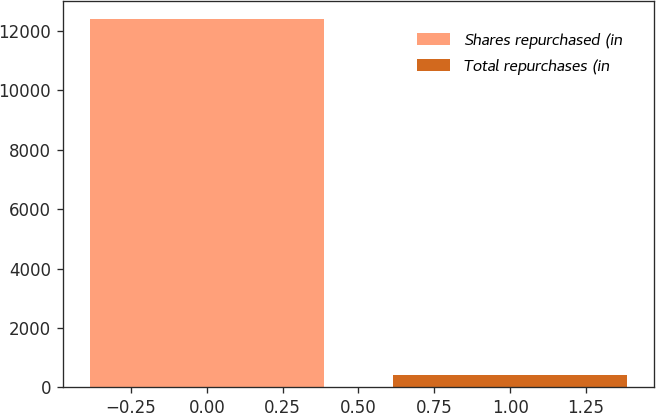<chart> <loc_0><loc_0><loc_500><loc_500><bar_chart><fcel>Shares repurchased (in<fcel>Total repurchases (in<nl><fcel>12390<fcel>410<nl></chart> 